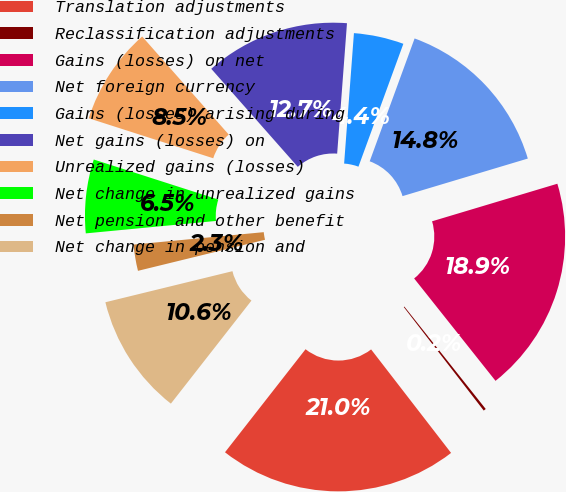<chart> <loc_0><loc_0><loc_500><loc_500><pie_chart><fcel>Translation adjustments<fcel>Reclassification adjustments<fcel>Gains (losses) on net<fcel>Net foreign currency<fcel>Gains (losses) arising during<fcel>Net gains (losses) on<fcel>Unrealized gains (losses)<fcel>Net change in unrealized gains<fcel>Net pension and other benefit<fcel>Net change in pension and<nl><fcel>21.02%<fcel>0.22%<fcel>18.94%<fcel>14.78%<fcel>4.38%<fcel>12.7%<fcel>8.54%<fcel>6.46%<fcel>2.3%<fcel>10.62%<nl></chart> 